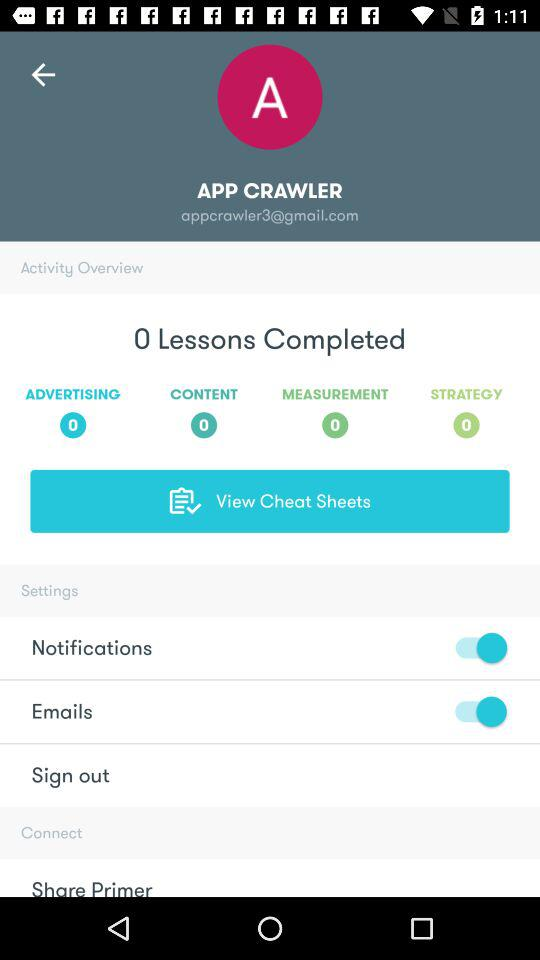What is the email address given? The email address given is "appcrawler3@gmail.com". 